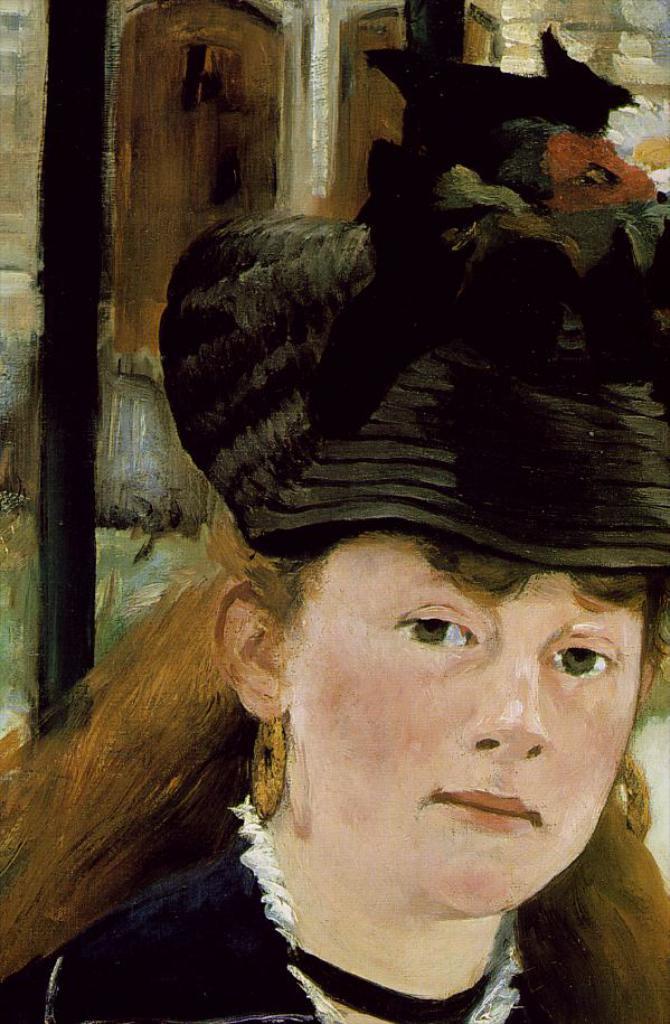Could you give a brief overview of what you see in this image? This is a painting of a lady wearing earrings and a hat. On the hat there are flowers. 